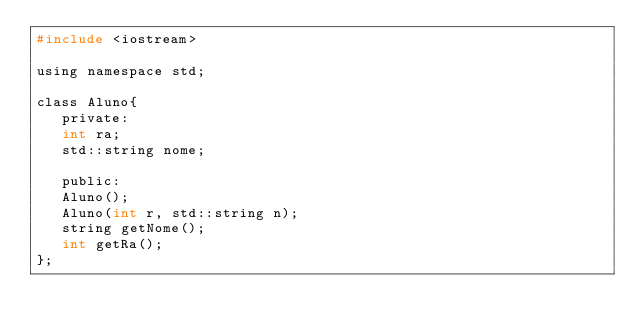<code> <loc_0><loc_0><loc_500><loc_500><_C_>#include <iostream>

using namespace std;

class Aluno{
   private:
   int ra;
   std::string nome;

   public:
   Aluno();
   Aluno(int r, std::string n);
   string getNome();
   int getRa();
};</code> 